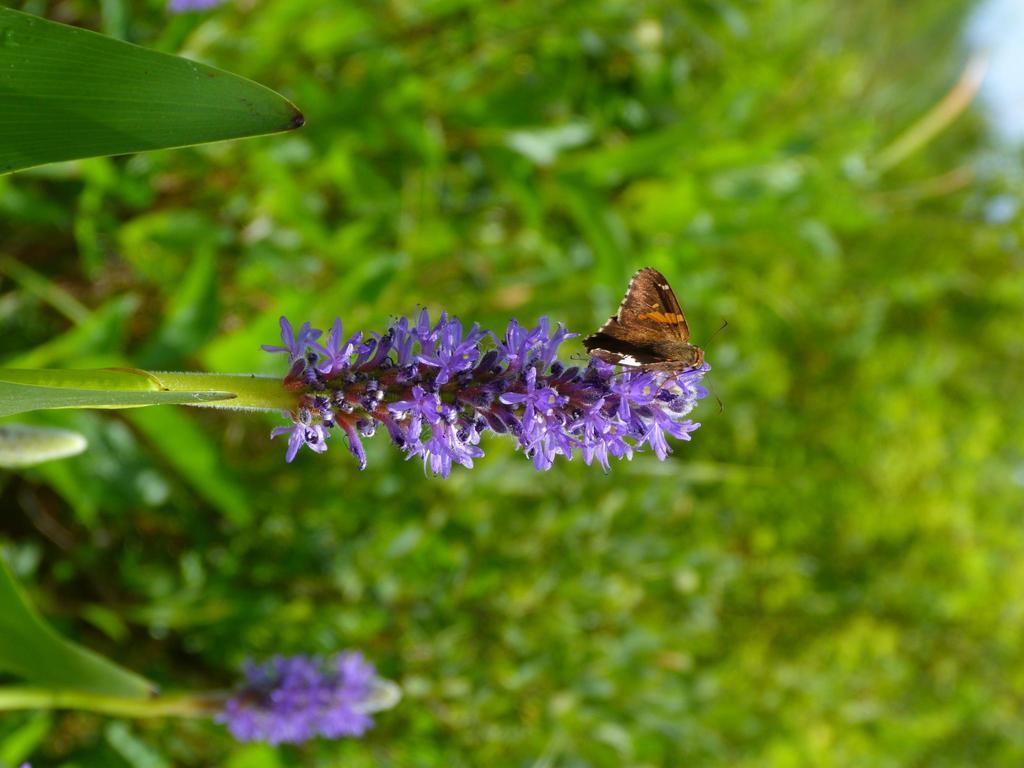Please provide a concise description of this image. In the image we can see the purple color flower and this is a stem of the flower. There is even a butterfly stick to the flower, these are the leaves and the background is blurred. 